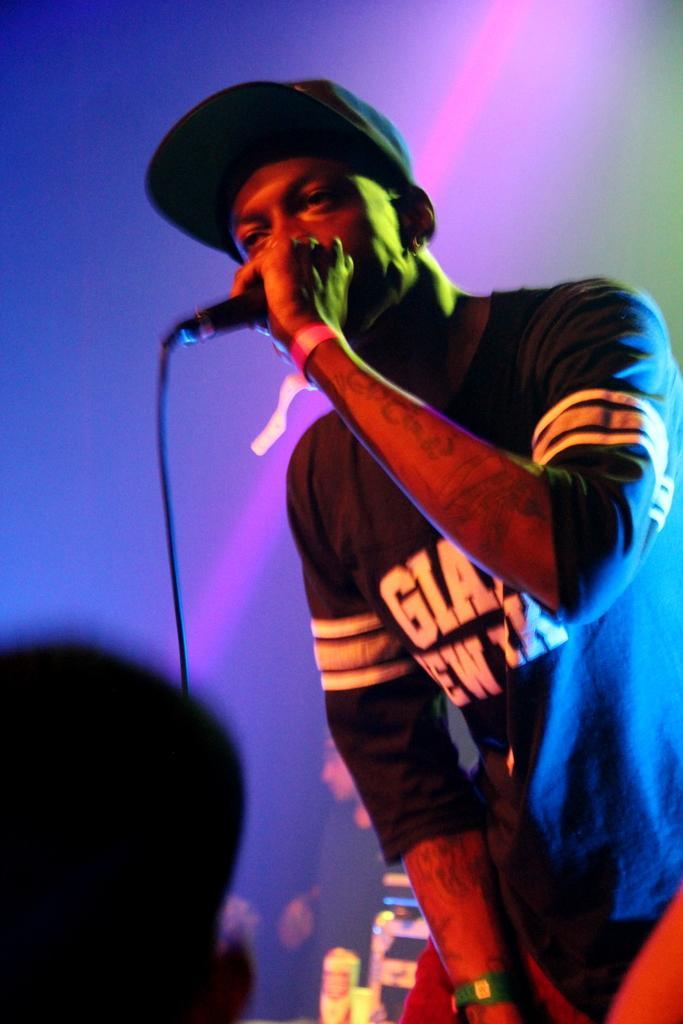How would you summarize this image in a sentence or two? Here in this picture we can see a person standing on a stage and singing something in the microphone present in his hand and he is wearing cap on him and we can see people standing behind him over there. 